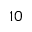<formula> <loc_0><loc_0><loc_500><loc_500>1 0</formula> 